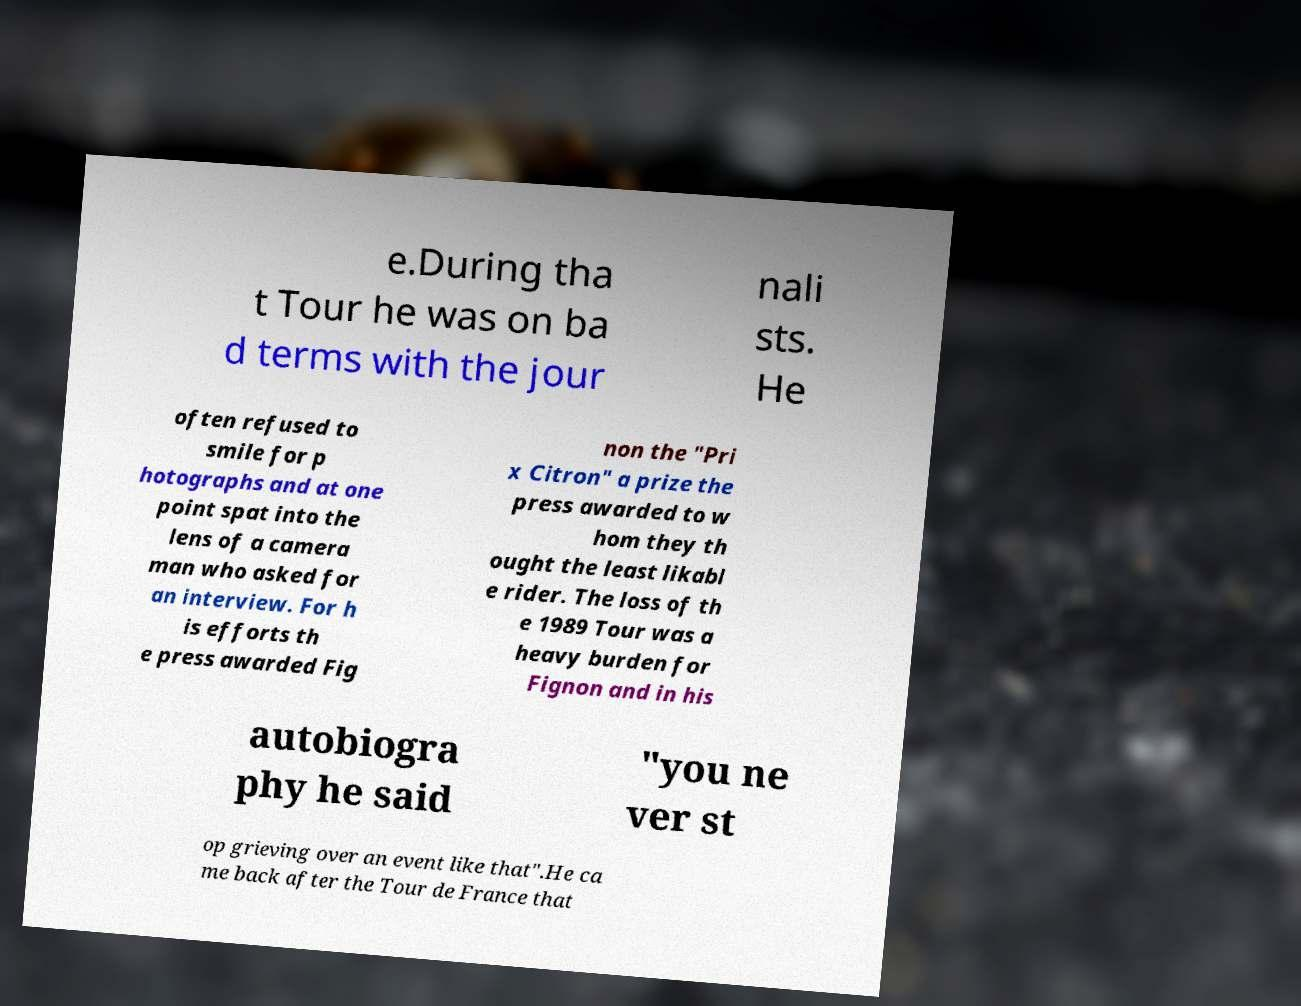For documentation purposes, I need the text within this image transcribed. Could you provide that? e.During tha t Tour he was on ba d terms with the jour nali sts. He often refused to smile for p hotographs and at one point spat into the lens of a camera man who asked for an interview. For h is efforts th e press awarded Fig non the "Pri x Citron" a prize the press awarded to w hom they th ought the least likabl e rider. The loss of th e 1989 Tour was a heavy burden for Fignon and in his autobiogra phy he said "you ne ver st op grieving over an event like that".He ca me back after the Tour de France that 